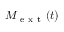<formula> <loc_0><loc_0><loc_500><loc_500>M _ { e x t } ( t )</formula> 